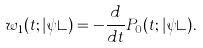Convert formula to latex. <formula><loc_0><loc_0><loc_500><loc_500>w _ { 1 } ( t ; | \psi \rangle ) = - \frac { d } { d t } P _ { 0 } ( t ; | \psi \rangle ) .</formula> 